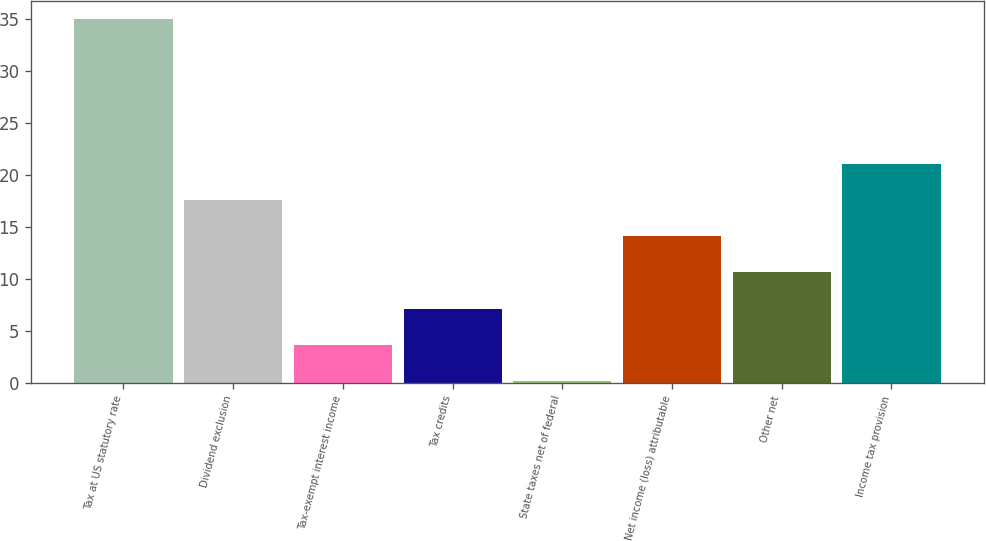<chart> <loc_0><loc_0><loc_500><loc_500><bar_chart><fcel>Tax at US statutory rate<fcel>Dividend exclusion<fcel>Tax-exempt interest income<fcel>Tax credits<fcel>State taxes net of federal<fcel>Net income (loss) attributable<fcel>Other net<fcel>Income tax provision<nl><fcel>35<fcel>17.6<fcel>3.68<fcel>7.16<fcel>0.2<fcel>14.12<fcel>10.64<fcel>21.08<nl></chart> 